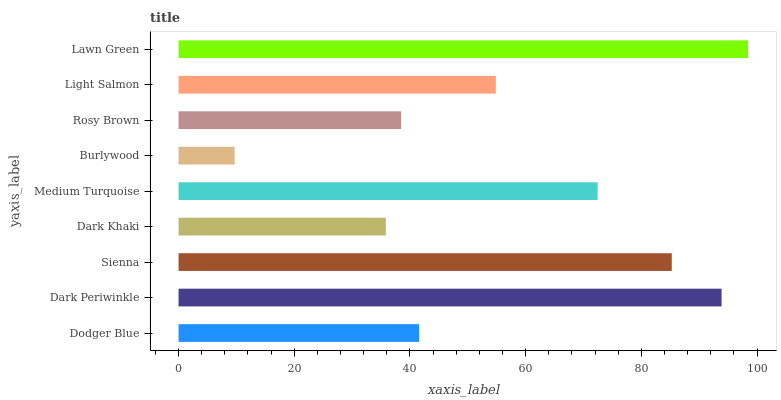Is Burlywood the minimum?
Answer yes or no. Yes. Is Lawn Green the maximum?
Answer yes or no. Yes. Is Dark Periwinkle the minimum?
Answer yes or no. No. Is Dark Periwinkle the maximum?
Answer yes or no. No. Is Dark Periwinkle greater than Dodger Blue?
Answer yes or no. Yes. Is Dodger Blue less than Dark Periwinkle?
Answer yes or no. Yes. Is Dodger Blue greater than Dark Periwinkle?
Answer yes or no. No. Is Dark Periwinkle less than Dodger Blue?
Answer yes or no. No. Is Light Salmon the high median?
Answer yes or no. Yes. Is Light Salmon the low median?
Answer yes or no. Yes. Is Lawn Green the high median?
Answer yes or no. No. Is Burlywood the low median?
Answer yes or no. No. 